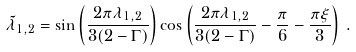<formula> <loc_0><loc_0><loc_500><loc_500>\tilde { \lambda } _ { 1 , 2 } = \sin \left ( \frac { 2 \pi \lambda _ { 1 , 2 } } { 3 ( 2 - \Gamma ) } \right ) \cos \left ( \frac { 2 \pi \lambda _ { 1 , 2 } } { 3 ( 2 - \Gamma ) } - \frac { \pi } { 6 } - \frac { \pi \xi } { 3 } \right ) \, .</formula> 